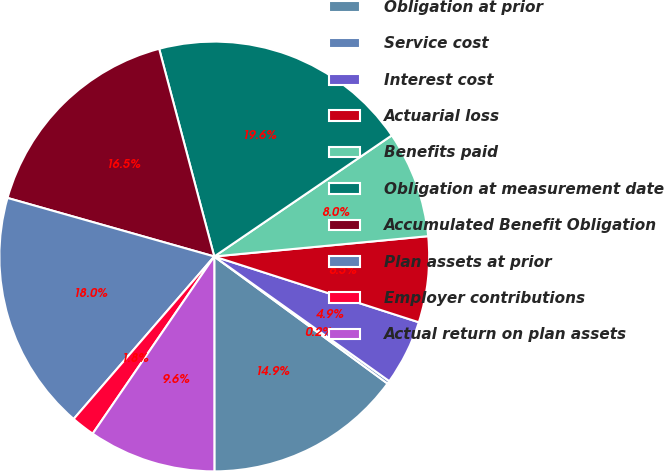<chart> <loc_0><loc_0><loc_500><loc_500><pie_chart><fcel>Obligation at prior<fcel>Service cost<fcel>Interest cost<fcel>Actuarial loss<fcel>Benefits paid<fcel>Obligation at measurement date<fcel>Accumulated Benefit Obligation<fcel>Plan assets at prior<fcel>Employer contributions<fcel>Actual return on plan assets<nl><fcel>14.92%<fcel>0.22%<fcel>4.9%<fcel>6.46%<fcel>8.02%<fcel>19.6%<fcel>16.48%<fcel>18.04%<fcel>1.78%<fcel>9.58%<nl></chart> 